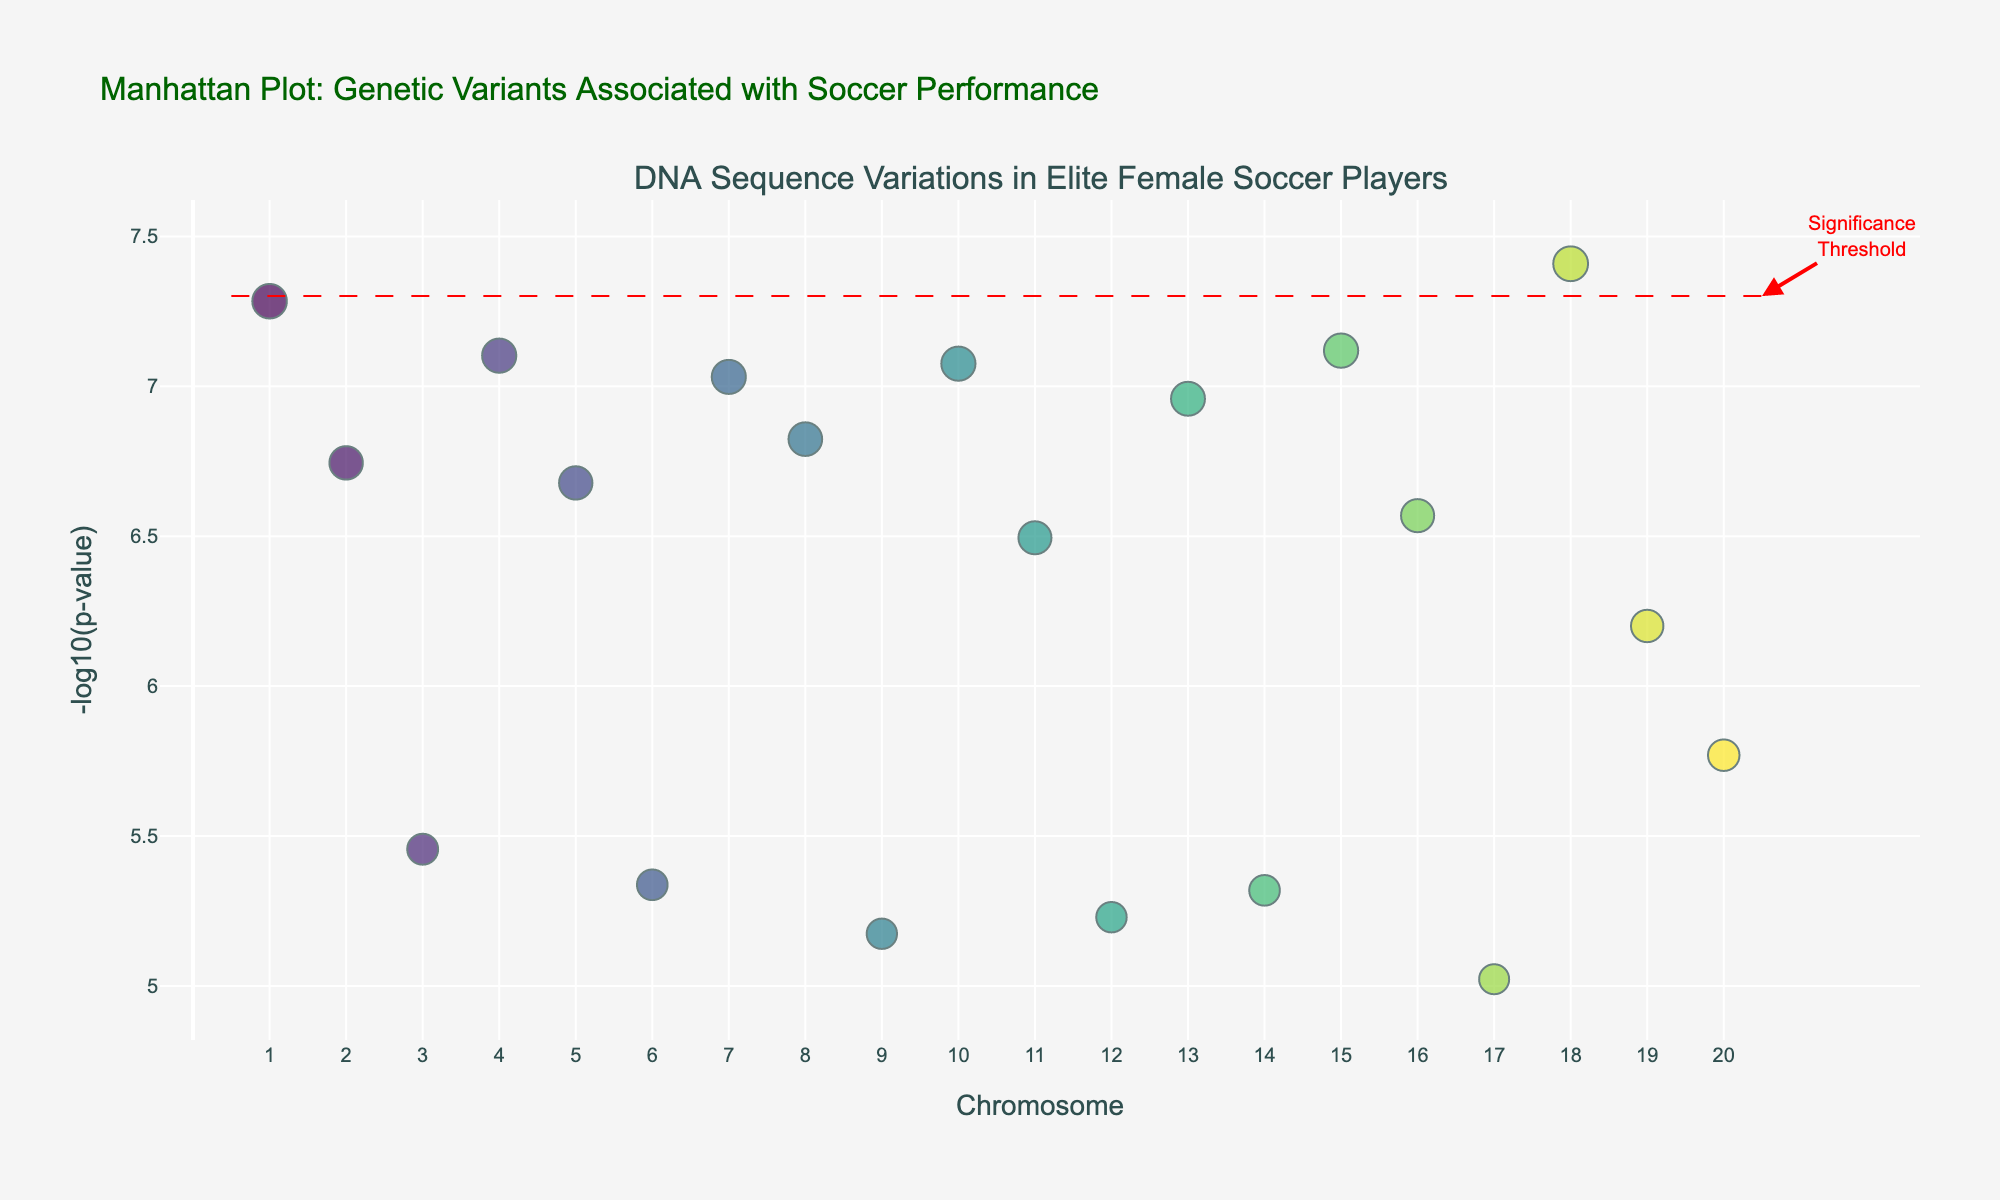What is the title of the figure? The title of the figure is written at the top and reads "Manhattan Plot: Genetic Variants Associated with Soccer Performance".
Answer: Manhattan Plot: Genetic Variants Associated with Soccer Performance What is represented on the x-axis? The x-axis represents the chromosome number, ranging from 1 to 20.
Answer: Chromosome number What does the y-axis show? The y-axis shows the -log10(p-value) of the genetic variants.
Answer: -log10(p-value) Which gene has the lowest p-value among the plotted points? To determine the lowest p-value, identify the point with the highest -log10(p-value). The highest -log10(p-value) is for the gene ACTN3 on chromosome 1.
Answer: ACTN3 How many genes are plotted above the significance threshold line? The significance threshold line is at -log10(5e-8). Count the number of points above this line. There are 11 genes plotted above this line.
Answer: 11 Which gene is associated with the trait "Blood vessel formation"? Look for the point corresponding to the gene VEGF and check its associated trait. The gene VEGF on chromosome 7 is associated with "Blood vessel formation".
Answer: VEGF What is the significance threshold value for the p-value on the plot? The significance threshold line is marked at -log10(5e-8). This corresponds to a p-value of 5e-8.
Answer: 5e-8 Which chromosome has the most genes plotted above the significance threshold? Identify the chromosome numbers with points above the -log10(p-value) threshold and count. Chromosome 1 has the most genes plotted above with two genes.
Answer: Chromosome 1 Compare the -log10(p-value) of genes on chromosome 2 with those on chromosome 8. Which chromosome has a higher max -log10(p-value)? Identify the highest -log10(p-value) for genes on chromosome 2 (PPARGC1A) and chromosome 8 (BDKRB2). Compare these values. Chromosome 2's highest is approximately 6.74, while chromosome 8's highest is approximately 6.82.
Answer: Chromosome 8 What is the -log10(p-value) for the gene associated with "Nitric oxide production"? Find the point for the gene NOS3 on chromosome 16 and read its -log10(p-value). It is about 6.57.
Answer: 6.57 